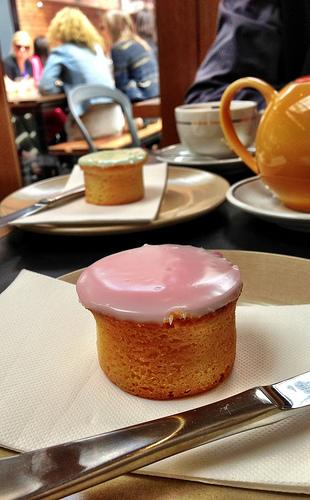Using a journalistic tone, describe the scenario depicted within the image. At a local gathering, patrons indulge in captivating conversation surrounded by appetizing cupcakes with colorful icing and a delightfully quirky orange teapot. Mention the significant objects and people in the image. The significant objects are cupcakes, a knife, a napkin, and an orange teapot, while the people are a group of women at a table. In a poetic style, describe the contents of the image. Amidst a gathering of ladies fair, lies a table with treats so rare; where frosted cupcakes entice, and an orange teapot adds flavor and spice. Briefly describe the prominent features seen in the image. There are several cupcakes with pink and yellow icing, a knife next to a napkin, an orange teapot on a plate, and people sitting at a table. Describe the picture in a casual tone, as if you were talking to a friend. Hey, check out this cool pic of people chilling at a table with some yummy pink and yellow frosted cupcakes and a funky orange teapot! Briefly describe the color palette and visual elements present in the image. The image features bright and lively colors, such as pink and green on the cupcakes, orange on the teapot, and has people gathered around a table. Enumerate the key elements of the picture that catch your attention. 4. Group of people sitting together Express what the individuals in the photograph might be doing. A group of people, possibly friends or family, are enjoying a social gathering around a table adorned with cupcakes and a teapot. Explain the picture's main focus in one sentence. The main focus of the image is a table scene with delicious cupcakes, an orange teapot, and people sitting together. List the primary elements present in the scene. Cupcakes with frosting, knife, napkin, teapot, plates, people, chair, and table. 